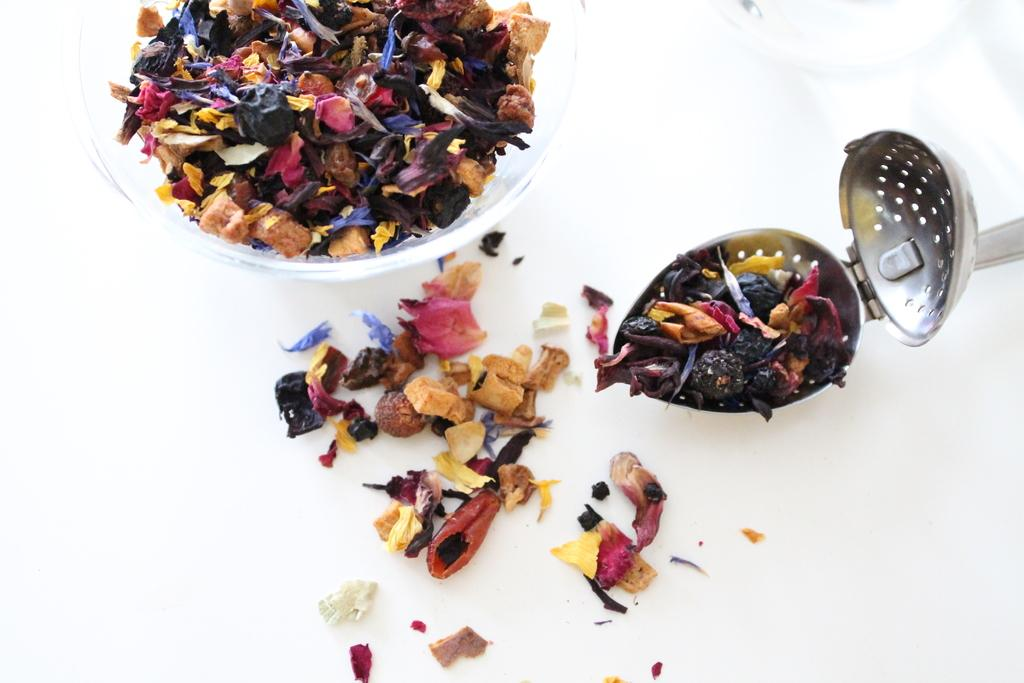What type of food is in the bowl in the image? There is a bowl containing superfoods in the image. What is happening to some of the superfoods in the image? Some superfoods have fallen beside the bowl. Can you describe the container on the right side of the image? There is a container with superfoods on the right side of the image. What is the reaction of the superfoods when they are exposed to sunlight in the image? There is no indication of sunlight or any reaction of the superfoods in the image. 